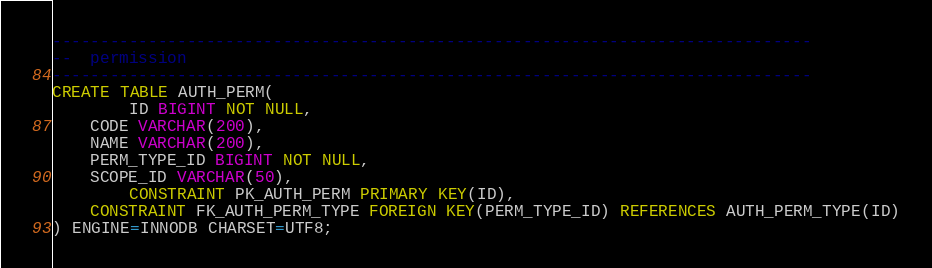Convert code to text. <code><loc_0><loc_0><loc_500><loc_500><_SQL_>-------------------------------------------------------------------------------
--  permission
-------------------------------------------------------------------------------
CREATE TABLE AUTH_PERM(
        ID BIGINT NOT NULL,
	CODE VARCHAR(200),
	NAME VARCHAR(200),
	PERM_TYPE_ID BIGINT NOT NULL,
	SCOPE_ID VARCHAR(50),
        CONSTRAINT PK_AUTH_PERM PRIMARY KEY(ID),
	CONSTRAINT FK_AUTH_PERM_TYPE FOREIGN KEY(PERM_TYPE_ID) REFERENCES AUTH_PERM_TYPE(ID)
) ENGINE=INNODB CHARSET=UTF8;







</code> 